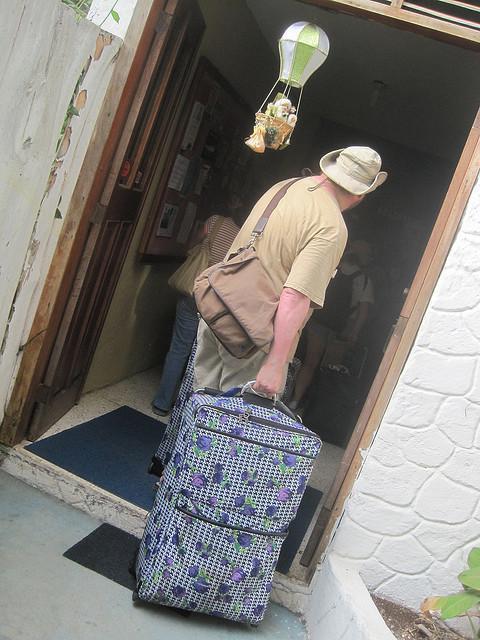How many people are in the picture?
Give a very brief answer. 3. 